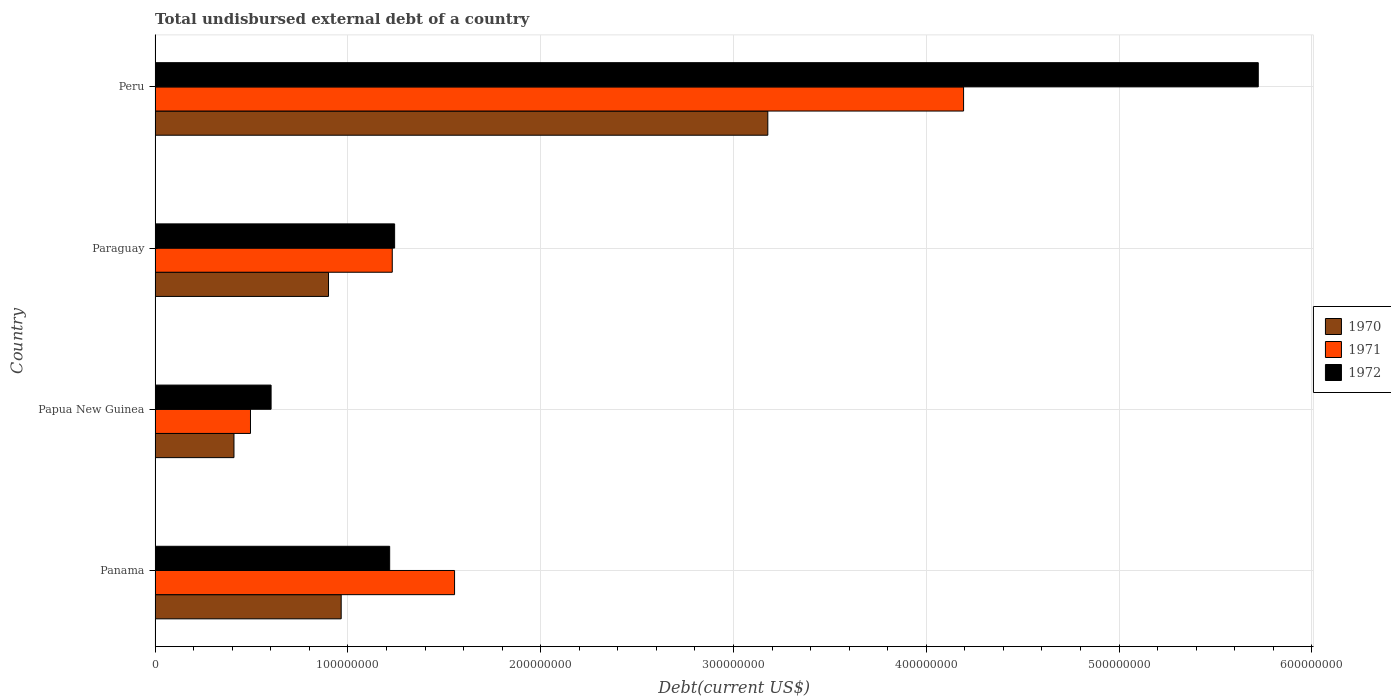How many different coloured bars are there?
Offer a very short reply. 3. How many groups of bars are there?
Your answer should be very brief. 4. Are the number of bars per tick equal to the number of legend labels?
Your answer should be very brief. Yes. Are the number of bars on each tick of the Y-axis equal?
Give a very brief answer. Yes. How many bars are there on the 3rd tick from the bottom?
Offer a terse response. 3. What is the label of the 2nd group of bars from the top?
Your answer should be very brief. Paraguay. In how many cases, is the number of bars for a given country not equal to the number of legend labels?
Provide a succinct answer. 0. What is the total undisbursed external debt in 1971 in Paraguay?
Give a very brief answer. 1.23e+08. Across all countries, what is the maximum total undisbursed external debt in 1970?
Your response must be concise. 3.18e+08. Across all countries, what is the minimum total undisbursed external debt in 1972?
Keep it short and to the point. 6.02e+07. In which country was the total undisbursed external debt in 1970 minimum?
Keep it short and to the point. Papua New Guinea. What is the total total undisbursed external debt in 1971 in the graph?
Provide a succinct answer. 7.47e+08. What is the difference between the total undisbursed external debt in 1970 in Panama and that in Paraguay?
Your answer should be compact. 6.58e+06. What is the difference between the total undisbursed external debt in 1971 in Peru and the total undisbursed external debt in 1970 in Paraguay?
Your answer should be very brief. 3.29e+08. What is the average total undisbursed external debt in 1970 per country?
Give a very brief answer. 1.36e+08. What is the difference between the total undisbursed external debt in 1971 and total undisbursed external debt in 1972 in Panama?
Provide a short and direct response. 3.37e+07. What is the ratio of the total undisbursed external debt in 1971 in Panama to that in Paraguay?
Ensure brevity in your answer.  1.26. Is the difference between the total undisbursed external debt in 1971 in Papua New Guinea and Peru greater than the difference between the total undisbursed external debt in 1972 in Papua New Guinea and Peru?
Your answer should be compact. Yes. What is the difference between the highest and the second highest total undisbursed external debt in 1970?
Offer a terse response. 2.21e+08. What is the difference between the highest and the lowest total undisbursed external debt in 1972?
Provide a succinct answer. 5.12e+08. What does the 3rd bar from the bottom in Panama represents?
Offer a terse response. 1972. Is it the case that in every country, the sum of the total undisbursed external debt in 1971 and total undisbursed external debt in 1970 is greater than the total undisbursed external debt in 1972?
Your answer should be compact. Yes. How many bars are there?
Keep it short and to the point. 12. What is the difference between two consecutive major ticks on the X-axis?
Your response must be concise. 1.00e+08. Does the graph contain any zero values?
Ensure brevity in your answer.  No. Does the graph contain grids?
Your answer should be very brief. Yes. How many legend labels are there?
Offer a terse response. 3. What is the title of the graph?
Offer a very short reply. Total undisbursed external debt of a country. What is the label or title of the X-axis?
Offer a very short reply. Debt(current US$). What is the Debt(current US$) in 1970 in Panama?
Offer a very short reply. 9.65e+07. What is the Debt(current US$) in 1971 in Panama?
Your answer should be very brief. 1.55e+08. What is the Debt(current US$) of 1972 in Panama?
Give a very brief answer. 1.22e+08. What is the Debt(current US$) in 1970 in Papua New Guinea?
Provide a short and direct response. 4.09e+07. What is the Debt(current US$) in 1971 in Papua New Guinea?
Your response must be concise. 4.95e+07. What is the Debt(current US$) of 1972 in Papua New Guinea?
Keep it short and to the point. 6.02e+07. What is the Debt(current US$) in 1970 in Paraguay?
Your response must be concise. 9.00e+07. What is the Debt(current US$) in 1971 in Paraguay?
Ensure brevity in your answer.  1.23e+08. What is the Debt(current US$) of 1972 in Paraguay?
Your answer should be compact. 1.24e+08. What is the Debt(current US$) in 1970 in Peru?
Your response must be concise. 3.18e+08. What is the Debt(current US$) in 1971 in Peru?
Your response must be concise. 4.19e+08. What is the Debt(current US$) in 1972 in Peru?
Offer a very short reply. 5.72e+08. Across all countries, what is the maximum Debt(current US$) of 1970?
Keep it short and to the point. 3.18e+08. Across all countries, what is the maximum Debt(current US$) of 1971?
Ensure brevity in your answer.  4.19e+08. Across all countries, what is the maximum Debt(current US$) of 1972?
Offer a terse response. 5.72e+08. Across all countries, what is the minimum Debt(current US$) in 1970?
Offer a terse response. 4.09e+07. Across all countries, what is the minimum Debt(current US$) of 1971?
Offer a very short reply. 4.95e+07. Across all countries, what is the minimum Debt(current US$) in 1972?
Give a very brief answer. 6.02e+07. What is the total Debt(current US$) in 1970 in the graph?
Your response must be concise. 5.45e+08. What is the total Debt(current US$) of 1971 in the graph?
Keep it short and to the point. 7.47e+08. What is the total Debt(current US$) in 1972 in the graph?
Your answer should be compact. 8.78e+08. What is the difference between the Debt(current US$) in 1970 in Panama and that in Papua New Guinea?
Ensure brevity in your answer.  5.56e+07. What is the difference between the Debt(current US$) of 1971 in Panama and that in Papua New Guinea?
Ensure brevity in your answer.  1.06e+08. What is the difference between the Debt(current US$) in 1972 in Panama and that in Papua New Guinea?
Keep it short and to the point. 6.15e+07. What is the difference between the Debt(current US$) of 1970 in Panama and that in Paraguay?
Your answer should be very brief. 6.58e+06. What is the difference between the Debt(current US$) of 1971 in Panama and that in Paraguay?
Offer a terse response. 3.23e+07. What is the difference between the Debt(current US$) of 1972 in Panama and that in Paraguay?
Ensure brevity in your answer.  -2.57e+06. What is the difference between the Debt(current US$) in 1970 in Panama and that in Peru?
Make the answer very short. -2.21e+08. What is the difference between the Debt(current US$) in 1971 in Panama and that in Peru?
Your answer should be compact. -2.64e+08. What is the difference between the Debt(current US$) of 1972 in Panama and that in Peru?
Give a very brief answer. -4.50e+08. What is the difference between the Debt(current US$) of 1970 in Papua New Guinea and that in Paraguay?
Ensure brevity in your answer.  -4.90e+07. What is the difference between the Debt(current US$) in 1971 in Papua New Guinea and that in Paraguay?
Provide a succinct answer. -7.35e+07. What is the difference between the Debt(current US$) in 1972 in Papua New Guinea and that in Paraguay?
Keep it short and to the point. -6.41e+07. What is the difference between the Debt(current US$) of 1970 in Papua New Guinea and that in Peru?
Your answer should be compact. -2.77e+08. What is the difference between the Debt(current US$) in 1971 in Papua New Guinea and that in Peru?
Your answer should be compact. -3.70e+08. What is the difference between the Debt(current US$) of 1972 in Papua New Guinea and that in Peru?
Provide a short and direct response. -5.12e+08. What is the difference between the Debt(current US$) in 1970 in Paraguay and that in Peru?
Make the answer very short. -2.28e+08. What is the difference between the Debt(current US$) in 1971 in Paraguay and that in Peru?
Your answer should be very brief. -2.96e+08. What is the difference between the Debt(current US$) of 1972 in Paraguay and that in Peru?
Provide a short and direct response. -4.48e+08. What is the difference between the Debt(current US$) in 1970 in Panama and the Debt(current US$) in 1971 in Papua New Guinea?
Your answer should be compact. 4.70e+07. What is the difference between the Debt(current US$) of 1970 in Panama and the Debt(current US$) of 1972 in Papua New Guinea?
Ensure brevity in your answer.  3.64e+07. What is the difference between the Debt(current US$) in 1971 in Panama and the Debt(current US$) in 1972 in Papua New Guinea?
Provide a short and direct response. 9.52e+07. What is the difference between the Debt(current US$) of 1970 in Panama and the Debt(current US$) of 1971 in Paraguay?
Your response must be concise. -2.65e+07. What is the difference between the Debt(current US$) in 1970 in Panama and the Debt(current US$) in 1972 in Paraguay?
Provide a short and direct response. -2.77e+07. What is the difference between the Debt(current US$) of 1971 in Panama and the Debt(current US$) of 1972 in Paraguay?
Your answer should be very brief. 3.11e+07. What is the difference between the Debt(current US$) in 1970 in Panama and the Debt(current US$) in 1971 in Peru?
Give a very brief answer. -3.23e+08. What is the difference between the Debt(current US$) in 1970 in Panama and the Debt(current US$) in 1972 in Peru?
Your answer should be compact. -4.76e+08. What is the difference between the Debt(current US$) of 1971 in Panama and the Debt(current US$) of 1972 in Peru?
Your answer should be compact. -4.17e+08. What is the difference between the Debt(current US$) of 1970 in Papua New Guinea and the Debt(current US$) of 1971 in Paraguay?
Make the answer very short. -8.21e+07. What is the difference between the Debt(current US$) in 1970 in Papua New Guinea and the Debt(current US$) in 1972 in Paraguay?
Your answer should be compact. -8.33e+07. What is the difference between the Debt(current US$) in 1971 in Papua New Guinea and the Debt(current US$) in 1972 in Paraguay?
Offer a very short reply. -7.48e+07. What is the difference between the Debt(current US$) in 1970 in Papua New Guinea and the Debt(current US$) in 1971 in Peru?
Keep it short and to the point. -3.78e+08. What is the difference between the Debt(current US$) of 1970 in Papua New Guinea and the Debt(current US$) of 1972 in Peru?
Keep it short and to the point. -5.31e+08. What is the difference between the Debt(current US$) of 1971 in Papua New Guinea and the Debt(current US$) of 1972 in Peru?
Give a very brief answer. -5.23e+08. What is the difference between the Debt(current US$) in 1970 in Paraguay and the Debt(current US$) in 1971 in Peru?
Ensure brevity in your answer.  -3.29e+08. What is the difference between the Debt(current US$) in 1970 in Paraguay and the Debt(current US$) in 1972 in Peru?
Offer a terse response. -4.82e+08. What is the difference between the Debt(current US$) of 1971 in Paraguay and the Debt(current US$) of 1972 in Peru?
Offer a very short reply. -4.49e+08. What is the average Debt(current US$) in 1970 per country?
Make the answer very short. 1.36e+08. What is the average Debt(current US$) of 1971 per country?
Your answer should be very brief. 1.87e+08. What is the average Debt(current US$) in 1972 per country?
Provide a succinct answer. 2.20e+08. What is the difference between the Debt(current US$) of 1970 and Debt(current US$) of 1971 in Panama?
Keep it short and to the point. -5.88e+07. What is the difference between the Debt(current US$) in 1970 and Debt(current US$) in 1972 in Panama?
Offer a terse response. -2.51e+07. What is the difference between the Debt(current US$) of 1971 and Debt(current US$) of 1972 in Panama?
Keep it short and to the point. 3.37e+07. What is the difference between the Debt(current US$) in 1970 and Debt(current US$) in 1971 in Papua New Guinea?
Keep it short and to the point. -8.56e+06. What is the difference between the Debt(current US$) in 1970 and Debt(current US$) in 1972 in Papua New Guinea?
Offer a terse response. -1.93e+07. What is the difference between the Debt(current US$) of 1971 and Debt(current US$) of 1972 in Papua New Guinea?
Offer a terse response. -1.07e+07. What is the difference between the Debt(current US$) of 1970 and Debt(current US$) of 1971 in Paraguay?
Offer a terse response. -3.31e+07. What is the difference between the Debt(current US$) in 1970 and Debt(current US$) in 1972 in Paraguay?
Offer a very short reply. -3.43e+07. What is the difference between the Debt(current US$) of 1971 and Debt(current US$) of 1972 in Paraguay?
Provide a short and direct response. -1.22e+06. What is the difference between the Debt(current US$) in 1970 and Debt(current US$) in 1971 in Peru?
Your response must be concise. -1.02e+08. What is the difference between the Debt(current US$) in 1970 and Debt(current US$) in 1972 in Peru?
Make the answer very short. -2.54e+08. What is the difference between the Debt(current US$) of 1971 and Debt(current US$) of 1972 in Peru?
Your answer should be very brief. -1.53e+08. What is the ratio of the Debt(current US$) of 1970 in Panama to that in Papua New Guinea?
Provide a short and direct response. 2.36. What is the ratio of the Debt(current US$) in 1971 in Panama to that in Papua New Guinea?
Provide a short and direct response. 3.14. What is the ratio of the Debt(current US$) in 1972 in Panama to that in Papua New Guinea?
Your answer should be compact. 2.02. What is the ratio of the Debt(current US$) of 1970 in Panama to that in Paraguay?
Your answer should be very brief. 1.07. What is the ratio of the Debt(current US$) in 1971 in Panama to that in Paraguay?
Give a very brief answer. 1.26. What is the ratio of the Debt(current US$) in 1972 in Panama to that in Paraguay?
Give a very brief answer. 0.98. What is the ratio of the Debt(current US$) of 1970 in Panama to that in Peru?
Make the answer very short. 0.3. What is the ratio of the Debt(current US$) in 1971 in Panama to that in Peru?
Ensure brevity in your answer.  0.37. What is the ratio of the Debt(current US$) in 1972 in Panama to that in Peru?
Ensure brevity in your answer.  0.21. What is the ratio of the Debt(current US$) in 1970 in Papua New Guinea to that in Paraguay?
Your answer should be compact. 0.46. What is the ratio of the Debt(current US$) in 1971 in Papua New Guinea to that in Paraguay?
Offer a very short reply. 0.4. What is the ratio of the Debt(current US$) of 1972 in Papua New Guinea to that in Paraguay?
Offer a terse response. 0.48. What is the ratio of the Debt(current US$) of 1970 in Papua New Guinea to that in Peru?
Provide a short and direct response. 0.13. What is the ratio of the Debt(current US$) of 1971 in Papua New Guinea to that in Peru?
Give a very brief answer. 0.12. What is the ratio of the Debt(current US$) of 1972 in Papua New Guinea to that in Peru?
Offer a very short reply. 0.11. What is the ratio of the Debt(current US$) of 1970 in Paraguay to that in Peru?
Offer a terse response. 0.28. What is the ratio of the Debt(current US$) of 1971 in Paraguay to that in Peru?
Keep it short and to the point. 0.29. What is the ratio of the Debt(current US$) of 1972 in Paraguay to that in Peru?
Your response must be concise. 0.22. What is the difference between the highest and the second highest Debt(current US$) in 1970?
Offer a very short reply. 2.21e+08. What is the difference between the highest and the second highest Debt(current US$) in 1971?
Provide a short and direct response. 2.64e+08. What is the difference between the highest and the second highest Debt(current US$) in 1972?
Keep it short and to the point. 4.48e+08. What is the difference between the highest and the lowest Debt(current US$) in 1970?
Provide a short and direct response. 2.77e+08. What is the difference between the highest and the lowest Debt(current US$) of 1971?
Give a very brief answer. 3.70e+08. What is the difference between the highest and the lowest Debt(current US$) in 1972?
Your answer should be very brief. 5.12e+08. 